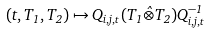Convert formula to latex. <formula><loc_0><loc_0><loc_500><loc_500>( t , T _ { 1 } , T _ { 2 } ) \mapsto Q _ { i , j , t } ( T _ { 1 } \hat { \otimes } T _ { 2 } ) Q _ { i , j , t } ^ { - 1 }</formula> 